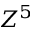Convert formula to latex. <formula><loc_0><loc_0><loc_500><loc_500>Z ^ { 5 }</formula> 